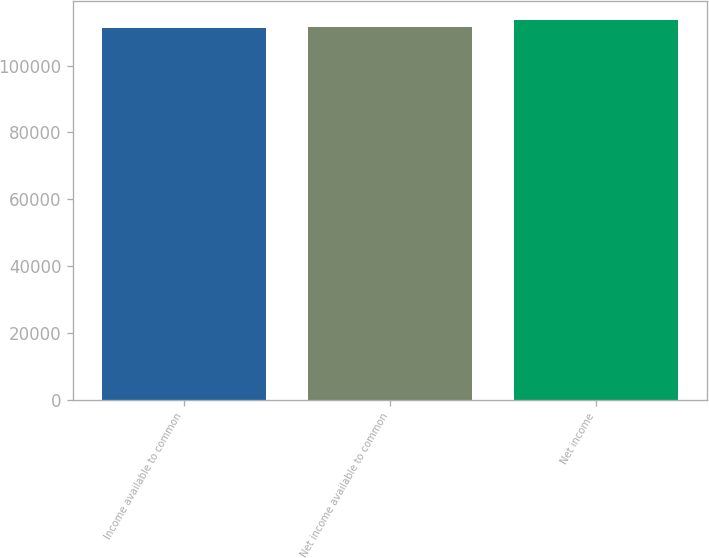Convert chart. <chart><loc_0><loc_0><loc_500><loc_500><bar_chart><fcel>Income available to common<fcel>Net income available to common<fcel>Net income<nl><fcel>111274<fcel>111502<fcel>113559<nl></chart> 